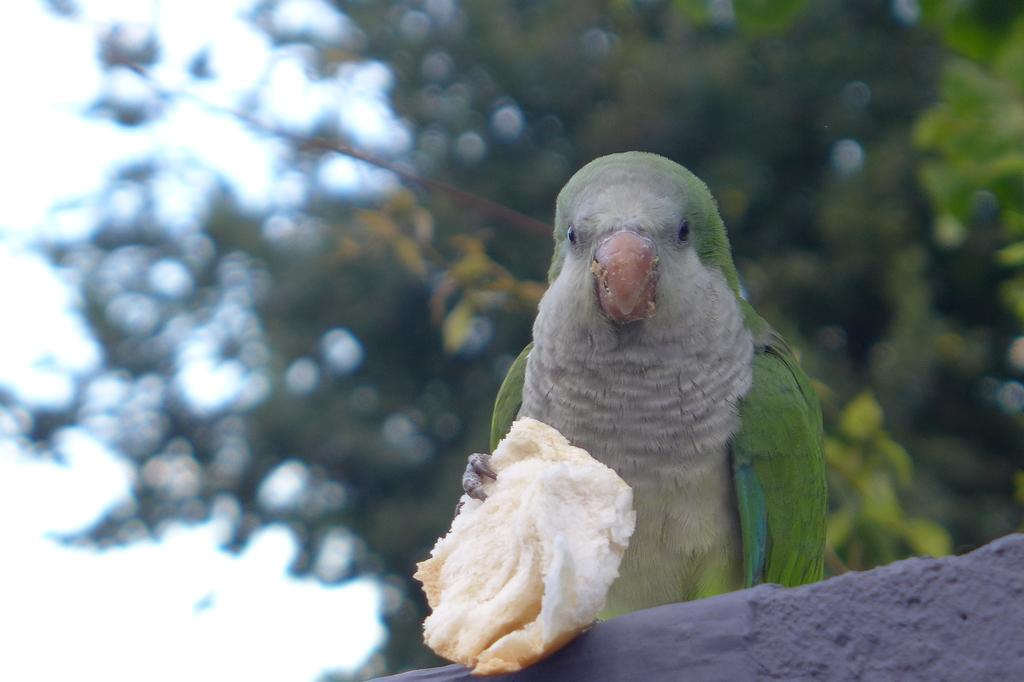What type of animal is in the image? There is a parrot in the image. What is the parrot holding in the image? The parrot is holding a food item. What can be seen in the background of the image? There are trees in the background of the image. How would you describe the background of the image? The background of the image is blurred. What type of ear is visible on the parrot in the image? Parrots do not have human-like ears, so there is no ear visible on the parrot in the image. 